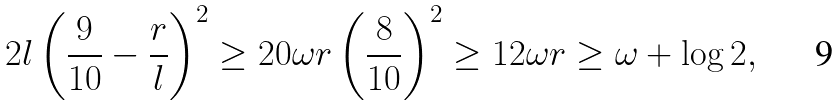<formula> <loc_0><loc_0><loc_500><loc_500>2 l \left ( \frac { 9 } { 1 0 } - \frac { r } { l } \right ) ^ { 2 } \geq 2 0 \omega r \left ( \frac { 8 } { 1 0 } \right ) ^ { 2 } \geq 1 2 \omega r \geq \omega + \log 2 ,</formula> 